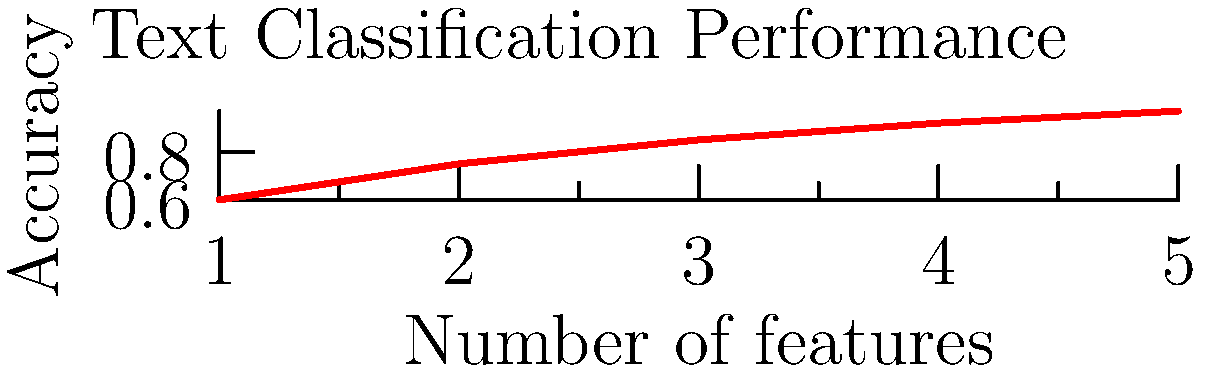Based on the graph showing the performance of a text classification model for identifying fake news articles related to public health, what can be concluded about the relationship between the number of features used and the model's accuracy? To answer this question, let's analyze the graph step-by-step:

1. The x-axis represents the number of features used in the text classification model, ranging from 1 to 5.
2. The y-axis represents the accuracy of the model, ranging from 0.6 to 0.97 (or 60% to 97%).
3. The red line shows the relationship between the number of features and the model's accuracy.
4. We can observe that as the number of features increases, the accuracy of the model also increases.
5. However, the rate of increase in accuracy slows down as more features are added:
   - From 1 to 2 features, there's a significant jump in accuracy (from 0.6 to 0.75)
   - From 2 to 3 features, the increase is smaller but still noticeable (0.75 to 0.85)
   - From 3 to 4 and 4 to 5 features, the accuracy improvements are much smaller

6. This pattern suggests a diminishing returns effect, where adding more features beyond a certain point yields smaller improvements in accuracy.
7. The curve appears to be approaching an asymptote, indicating that there may be a limit to how much the accuracy can improve by adding more features.

Given these observations, we can conclude that there is a positive correlation between the number of features and accuracy, but with diminishing returns as more features are added.
Answer: Positive correlation with diminishing returns 